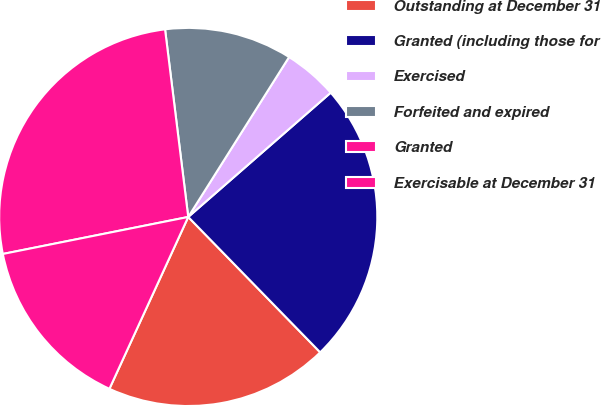<chart> <loc_0><loc_0><loc_500><loc_500><pie_chart><fcel>Outstanding at December 31<fcel>Granted (including those for<fcel>Exercised<fcel>Forfeited and expired<fcel>Granted<fcel>Exercisable at December 31<nl><fcel>19.14%<fcel>24.12%<fcel>4.63%<fcel>10.91%<fcel>26.18%<fcel>15.02%<nl></chart> 